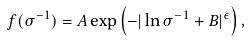<formula> <loc_0><loc_0><loc_500><loc_500>f ( \sigma ^ { - 1 } ) = A \exp \left ( - | \ln \sigma ^ { - 1 } + B | ^ { \epsilon } \right ) ,</formula> 